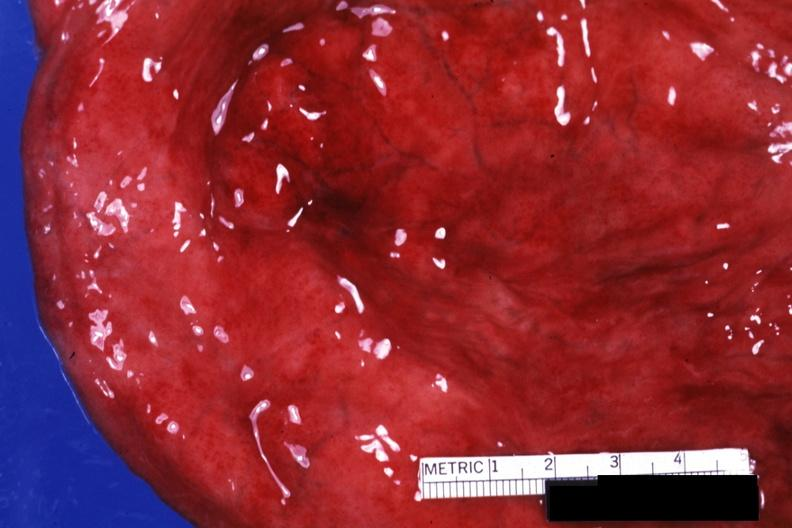what is present?
Answer the question using a single word or phrase. Urinary 